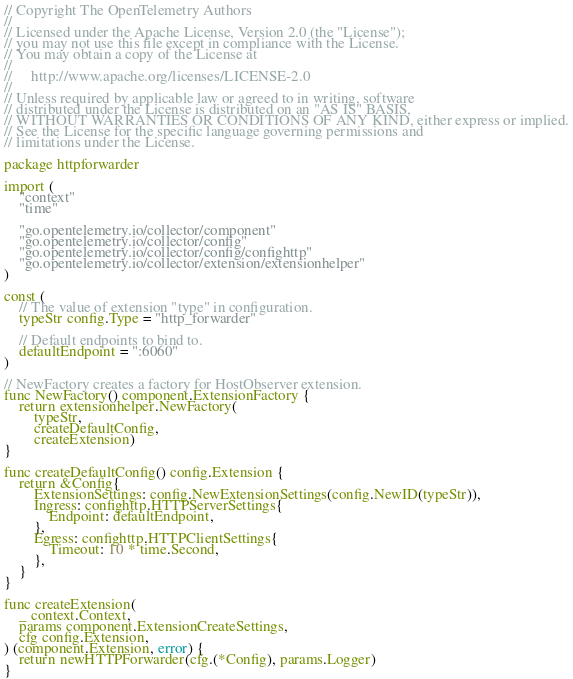<code> <loc_0><loc_0><loc_500><loc_500><_Go_>// Copyright The OpenTelemetry Authors
//
// Licensed under the Apache License, Version 2.0 (the "License");
// you may not use this file except in compliance with the License.
// You may obtain a copy of the License at
//
//     http://www.apache.org/licenses/LICENSE-2.0
//
// Unless required by applicable law or agreed to in writing, software
// distributed under the License is distributed on an "AS IS" BASIS,
// WITHOUT WARRANTIES OR CONDITIONS OF ANY KIND, either express or implied.
// See the License for the specific language governing permissions and
// limitations under the License.

package httpforwarder

import (
	"context"
	"time"

	"go.opentelemetry.io/collector/component"
	"go.opentelemetry.io/collector/config"
	"go.opentelemetry.io/collector/config/confighttp"
	"go.opentelemetry.io/collector/extension/extensionhelper"
)

const (
	// The value of extension "type" in configuration.
	typeStr config.Type = "http_forwarder"

	// Default endpoints to bind to.
	defaultEndpoint = ":6060"
)

// NewFactory creates a factory for HostObserver extension.
func NewFactory() component.ExtensionFactory {
	return extensionhelper.NewFactory(
		typeStr,
		createDefaultConfig,
		createExtension)
}

func createDefaultConfig() config.Extension {
	return &Config{
		ExtensionSettings: config.NewExtensionSettings(config.NewID(typeStr)),
		Ingress: confighttp.HTTPServerSettings{
			Endpoint: defaultEndpoint,
		},
		Egress: confighttp.HTTPClientSettings{
			Timeout: 10 * time.Second,
		},
	}
}

func createExtension(
	_ context.Context,
	params component.ExtensionCreateSettings,
	cfg config.Extension,
) (component.Extension, error) {
	return newHTTPForwarder(cfg.(*Config), params.Logger)
}
</code> 